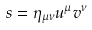Convert formula to latex. <formula><loc_0><loc_0><loc_500><loc_500>s = \eta _ { \mu \nu } u ^ { \mu } v ^ { \nu }</formula> 